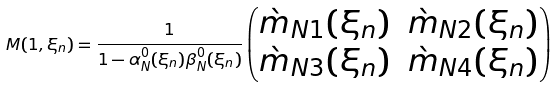<formula> <loc_0><loc_0><loc_500><loc_500>M ( 1 , \xi _ { n } ) = \frac { 1 } { 1 - \alpha _ { N } ^ { 0 } ( \xi _ { n } ) \beta _ { N } ^ { 0 } ( \xi _ { n } ) } \begin{pmatrix} \grave { m } _ { N 1 } ( \xi _ { n } ) & \grave { m } _ { N 2 } ( \xi _ { n } ) \\ \grave { m } _ { N 3 } ( \xi _ { n } ) & \grave { m } _ { N 4 } ( \xi _ { n } ) \end{pmatrix}</formula> 